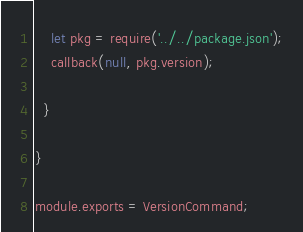<code> <loc_0><loc_0><loc_500><loc_500><_JavaScript_>
    let pkg = require('../../package.json');
    callback(null, pkg.version);

  }

}

module.exports = VersionCommand;
</code> 